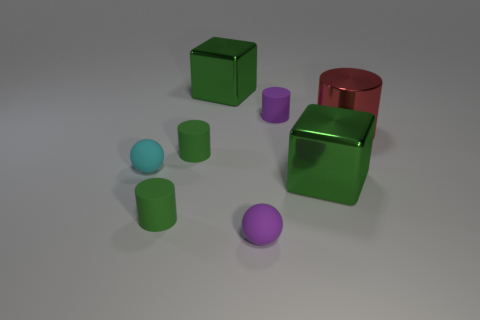Subtract all small purple matte cylinders. How many cylinders are left? 3 Subtract 1 cylinders. How many cylinders are left? 3 Subtract all purple cylinders. How many cylinders are left? 3 Add 1 small yellow spheres. How many objects exist? 9 Subtract all blue cylinders. Subtract all purple spheres. How many cylinders are left? 4 Subtract all blocks. How many objects are left? 6 Add 1 red metallic things. How many red metallic things are left? 2 Add 2 green blocks. How many green blocks exist? 4 Subtract 0 purple blocks. How many objects are left? 8 Subtract all small green things. Subtract all small cyan matte spheres. How many objects are left? 5 